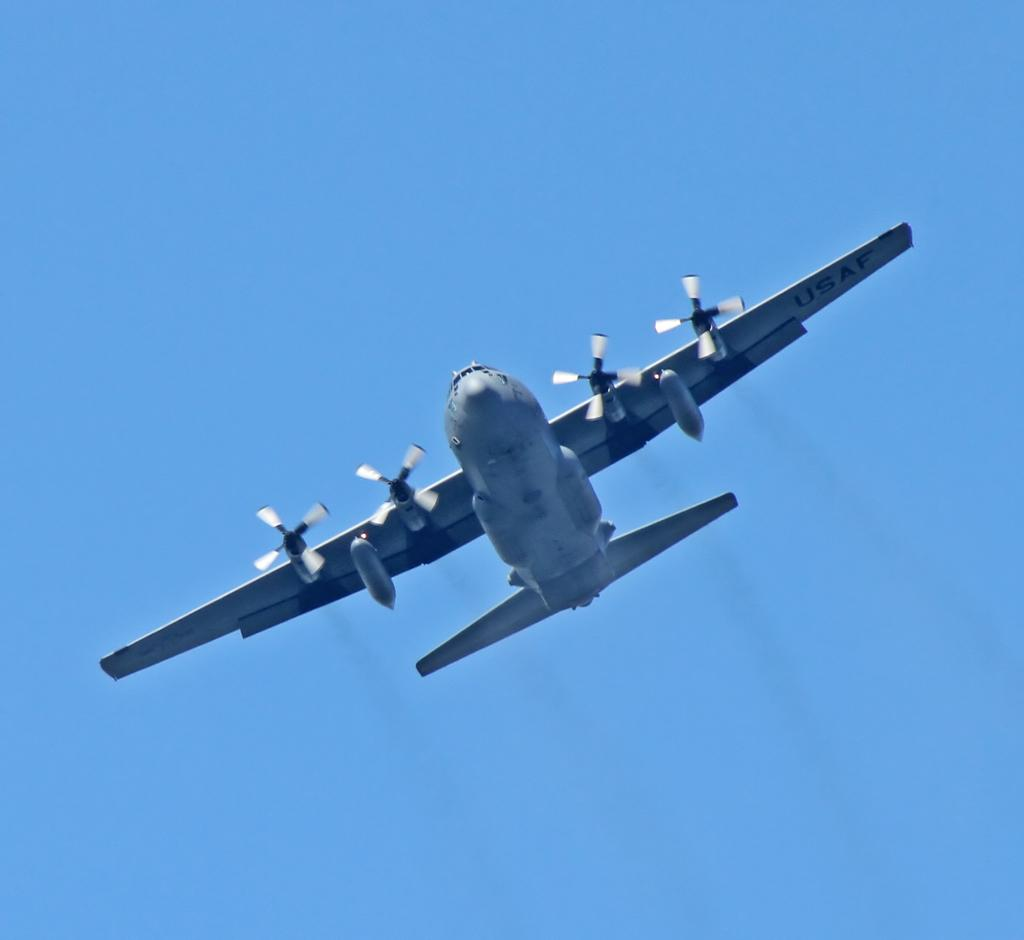What is the main subject of the image? The main subject of the image is an aeroplane. Can you describe the position of the aeroplane in the image? The aeroplane is in the air. What can be seen in the background of the image? There is sky visible in the background of the image. Where is the rabbit sitting in the image? There is no rabbit present in the image. What type of cable is connected to the aeroplane in the image? There is no cable connected to the aeroplane in the image. 